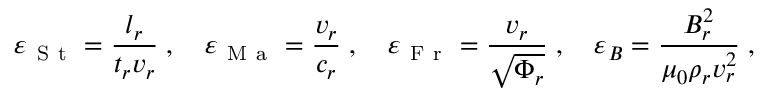Convert formula to latex. <formula><loc_0><loc_0><loc_500><loc_500>{ \varepsilon } _ { S t } = \frac { l _ { r } } { t _ { r } v _ { r } } \, , \quad \varepsilon _ { M a } = \frac { v _ { r } } { c _ { r } } \, , \quad \varepsilon _ { F r } = \frac { v _ { r } } { \sqrt { \Phi _ { r } } } \, , \quad \varepsilon _ { B } = \frac { B _ { r } ^ { 2 } } { \mu _ { 0 } \rho _ { r } v _ { r } ^ { 2 } } \, ,</formula> 